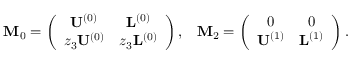<formula> <loc_0><loc_0><loc_500><loc_500>\begin{array} { r l r } & { M _ { 0 } = \left ( \begin{array} { c c } { U ^ { ( 0 ) } } & { L ^ { ( 0 ) } } \\ { z _ { 3 } U ^ { ( 0 ) } } & { z _ { 3 } L ^ { ( 0 ) } } \end{array} \right ) , } & { M _ { 2 } = \left ( \begin{array} { c c } { 0 } & { 0 } \\ { U ^ { ( 1 ) } } & { L ^ { ( 1 ) } } \end{array} \right ) . } \end{array}</formula> 